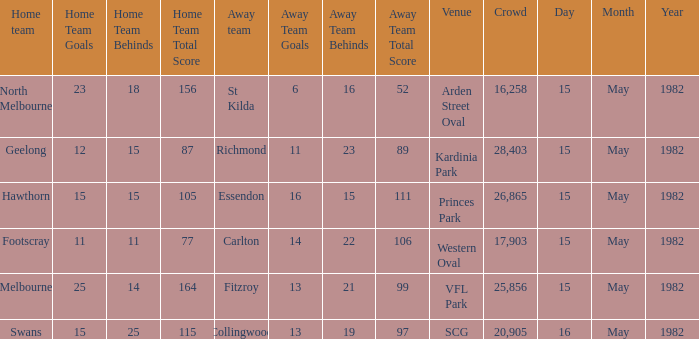What did the away team score when playing Footscray? 14.22 (106). 